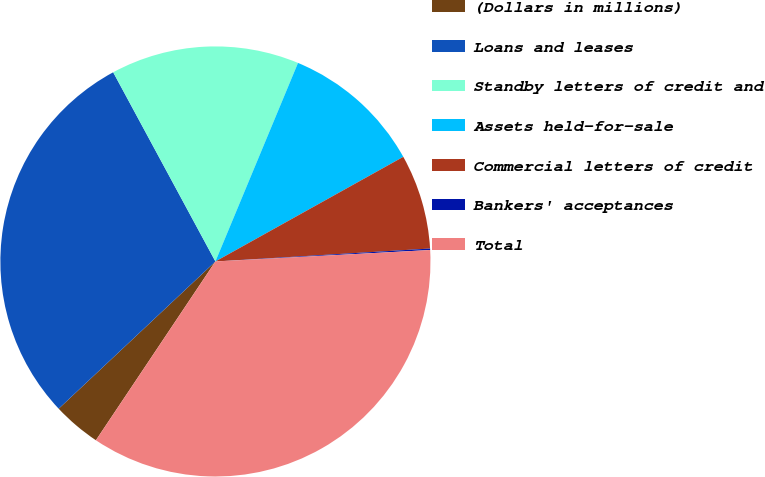<chart> <loc_0><loc_0><loc_500><loc_500><pie_chart><fcel>(Dollars in millions)<fcel>Loans and leases<fcel>Standby letters of credit and<fcel>Assets held-for-sale<fcel>Commercial letters of credit<fcel>Bankers' acceptances<fcel>Total<nl><fcel>3.62%<fcel>29.12%<fcel>14.16%<fcel>10.64%<fcel>7.13%<fcel>0.11%<fcel>35.23%<nl></chart> 